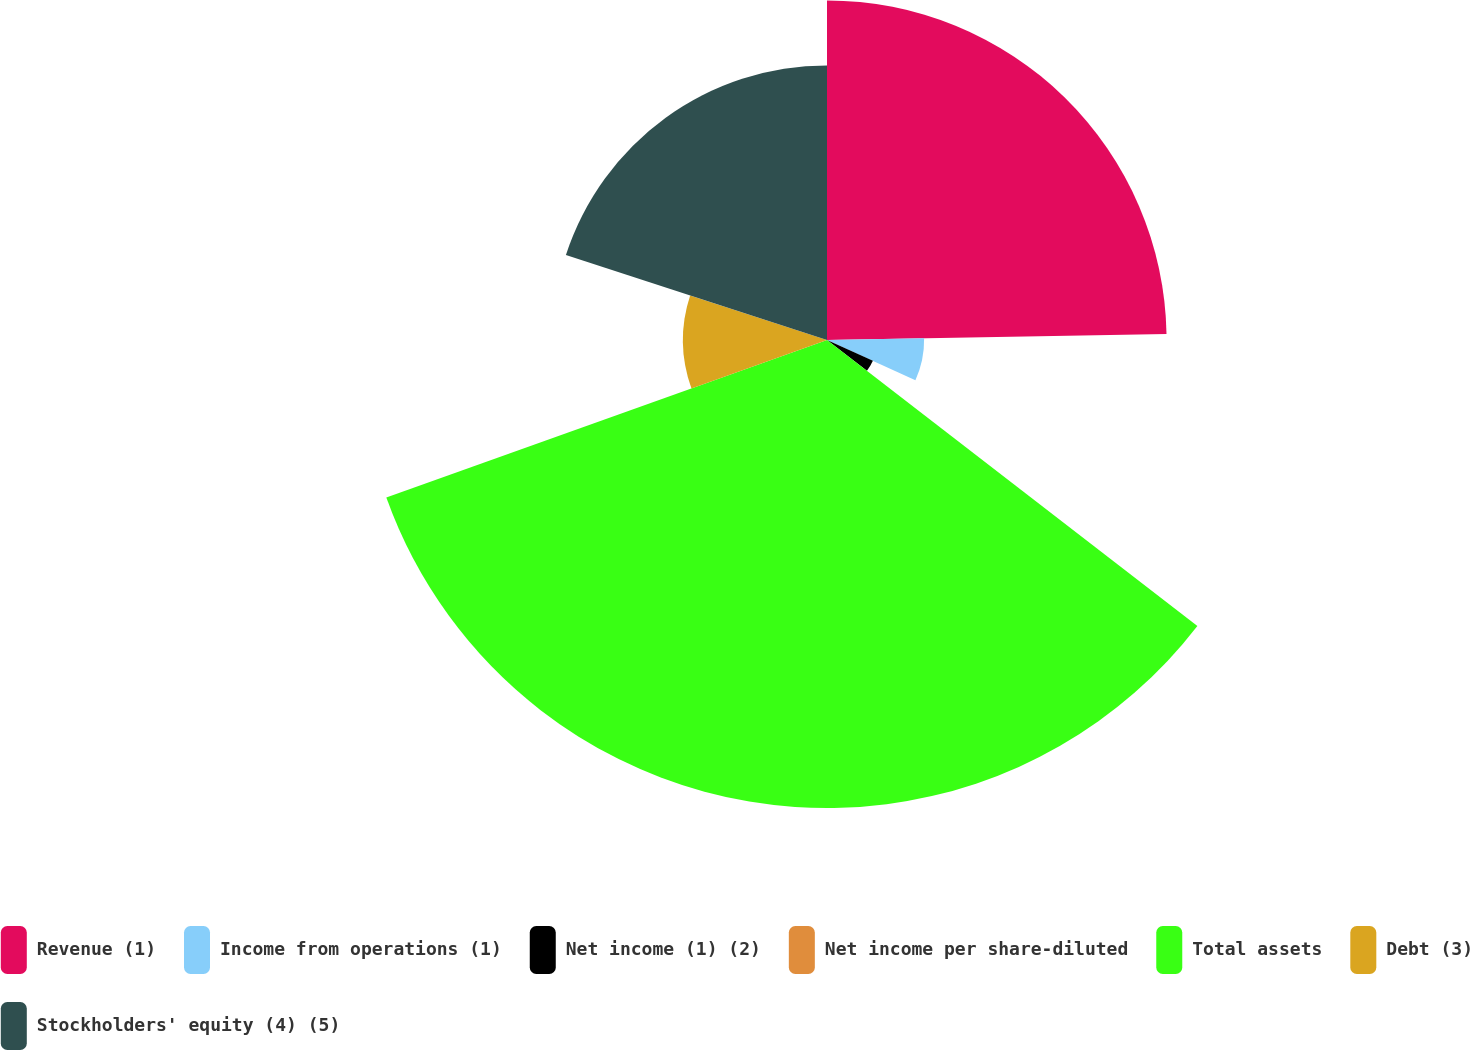Convert chart. <chart><loc_0><loc_0><loc_500><loc_500><pie_chart><fcel>Revenue (1)<fcel>Income from operations (1)<fcel>Net income (1) (2)<fcel>Net income per share-diluted<fcel>Total assets<fcel>Debt (3)<fcel>Stockholders' equity (4) (5)<nl><fcel>24.72%<fcel>7.07%<fcel>3.67%<fcel>0.01%<fcel>34.07%<fcel>10.48%<fcel>19.99%<nl></chart> 